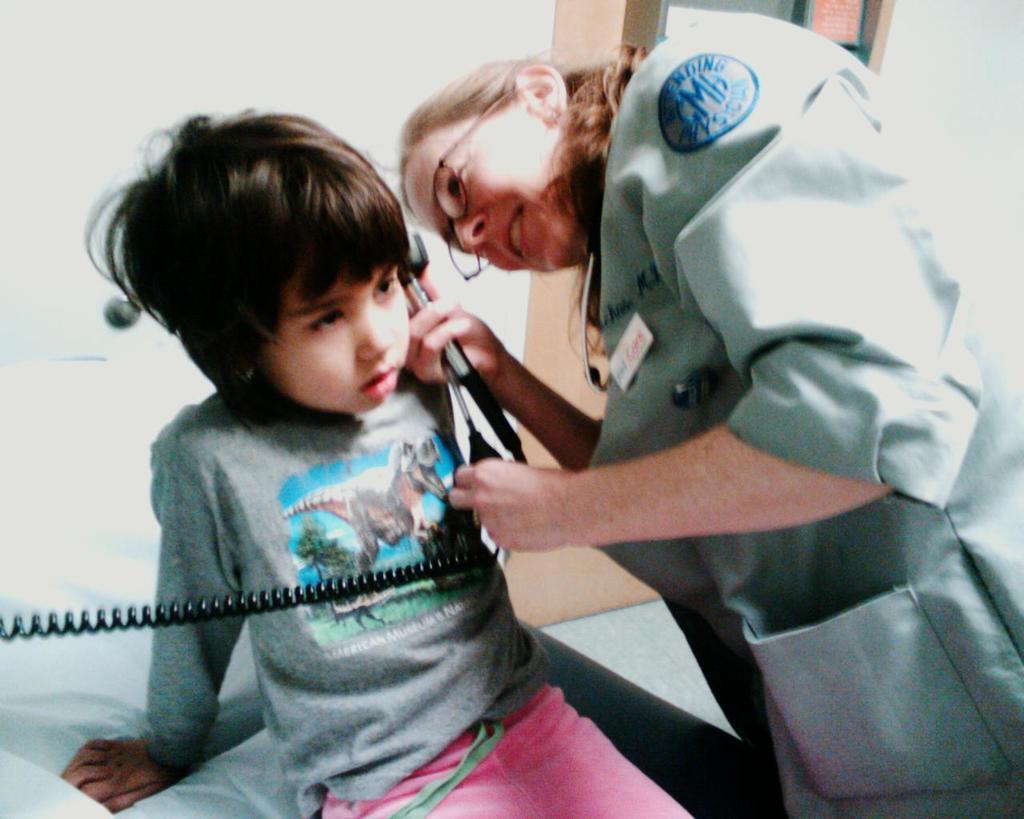In one or two sentences, can you explain what this image depicts? In this image we can see a woman is standing, she is wearing grey color dress. In front of her one girl is there who is sitting on white color thing and she is wearing grey t-shirt with pink pant and the lady is holding something in her hand. 